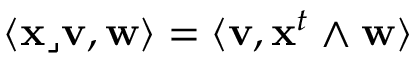Convert formula to latex. <formula><loc_0><loc_0><loc_500><loc_500>\langle x \lrcorner v , w \rangle = \langle v , x ^ { t } \wedge w \rangle</formula> 